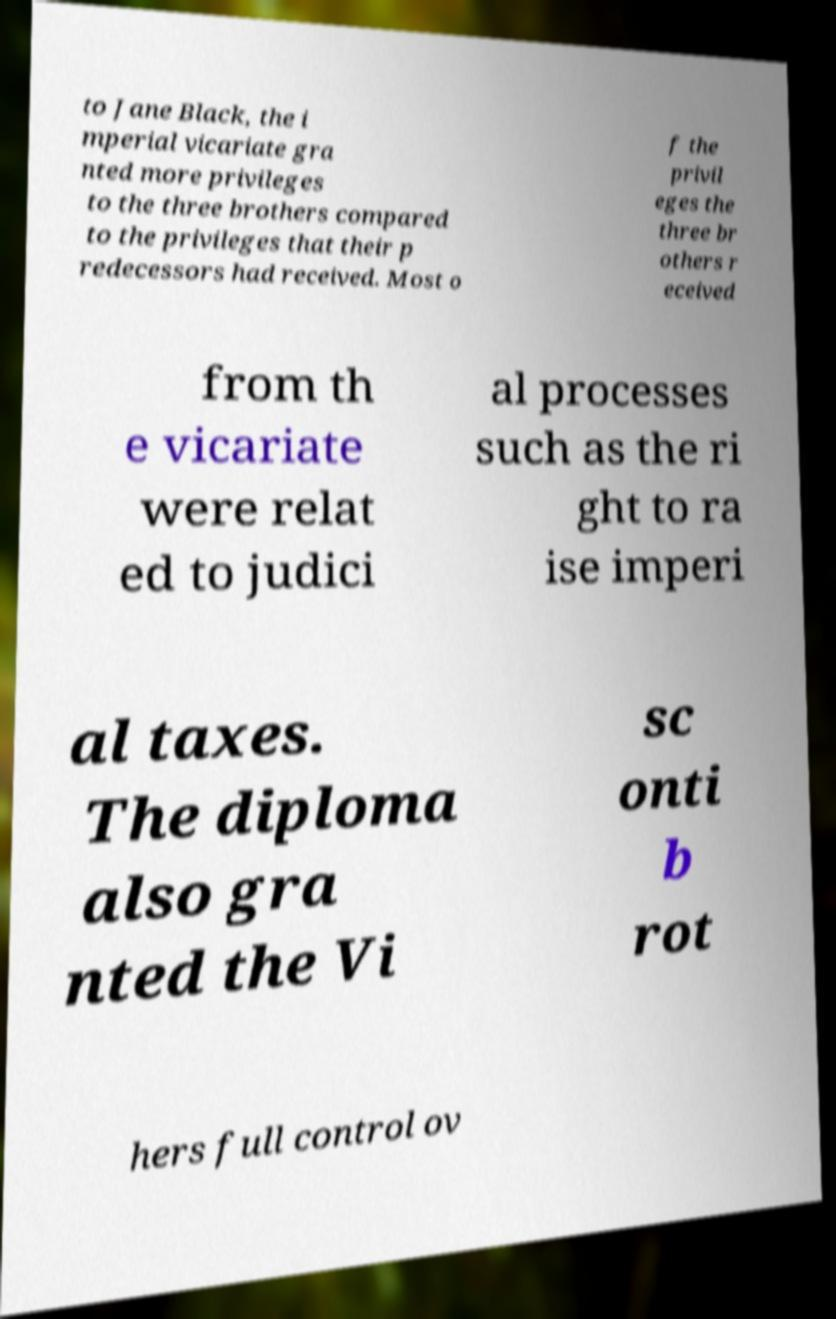Can you accurately transcribe the text from the provided image for me? to Jane Black, the i mperial vicariate gra nted more privileges to the three brothers compared to the privileges that their p redecessors had received. Most o f the privil eges the three br others r eceived from th e vicariate were relat ed to judici al processes such as the ri ght to ra ise imperi al taxes. The diploma also gra nted the Vi sc onti b rot hers full control ov 